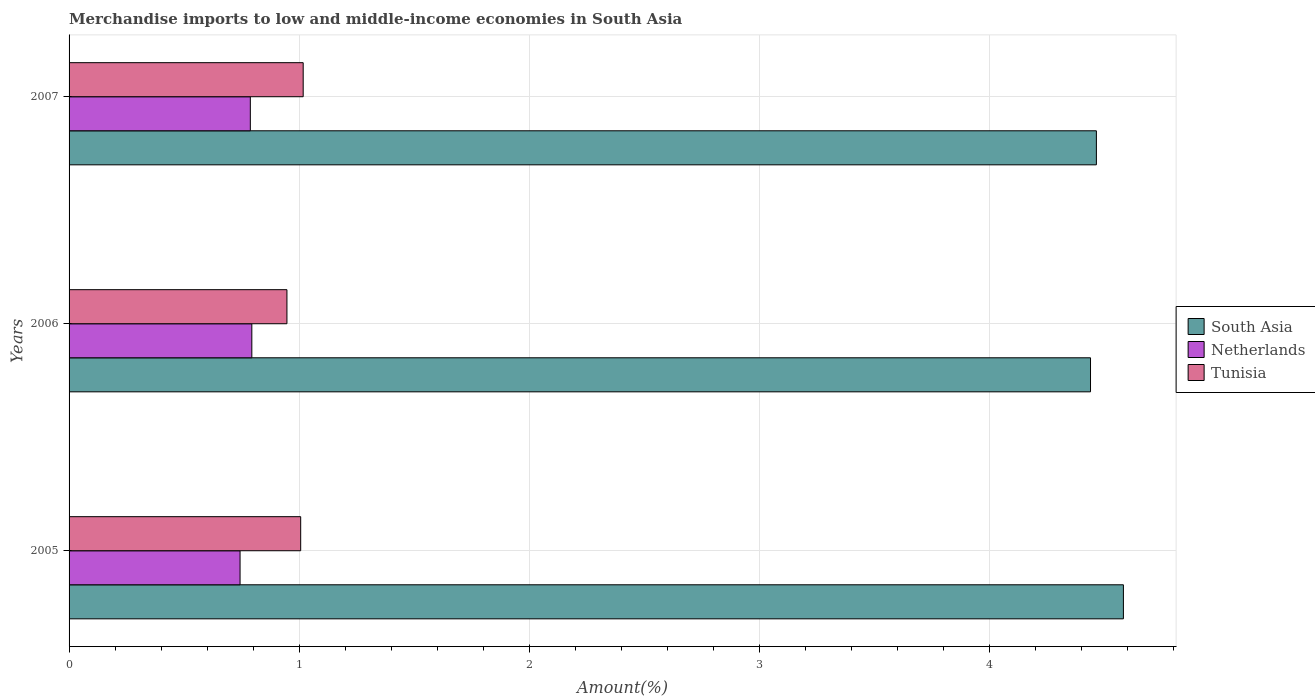How many different coloured bars are there?
Your answer should be compact. 3. How many bars are there on the 3rd tick from the top?
Make the answer very short. 3. What is the percentage of amount earned from merchandise imports in South Asia in 2007?
Offer a very short reply. 4.47. Across all years, what is the maximum percentage of amount earned from merchandise imports in Netherlands?
Make the answer very short. 0.79. Across all years, what is the minimum percentage of amount earned from merchandise imports in Tunisia?
Provide a short and direct response. 0.95. In which year was the percentage of amount earned from merchandise imports in Tunisia maximum?
Your response must be concise. 2007. In which year was the percentage of amount earned from merchandise imports in Tunisia minimum?
Offer a very short reply. 2006. What is the total percentage of amount earned from merchandise imports in South Asia in the graph?
Offer a terse response. 13.49. What is the difference between the percentage of amount earned from merchandise imports in Tunisia in 2005 and that in 2007?
Ensure brevity in your answer.  -0.01. What is the difference between the percentage of amount earned from merchandise imports in Tunisia in 2006 and the percentage of amount earned from merchandise imports in South Asia in 2007?
Give a very brief answer. -3.52. What is the average percentage of amount earned from merchandise imports in Tunisia per year?
Keep it short and to the point. 0.99. In the year 2006, what is the difference between the percentage of amount earned from merchandise imports in Netherlands and percentage of amount earned from merchandise imports in Tunisia?
Make the answer very short. -0.15. What is the ratio of the percentage of amount earned from merchandise imports in Tunisia in 2005 to that in 2006?
Offer a terse response. 1.06. What is the difference between the highest and the second highest percentage of amount earned from merchandise imports in South Asia?
Provide a short and direct response. 0.12. What is the difference between the highest and the lowest percentage of amount earned from merchandise imports in South Asia?
Your response must be concise. 0.14. In how many years, is the percentage of amount earned from merchandise imports in Tunisia greater than the average percentage of amount earned from merchandise imports in Tunisia taken over all years?
Your answer should be very brief. 2. What does the 2nd bar from the bottom in 2005 represents?
Offer a terse response. Netherlands. Is it the case that in every year, the sum of the percentage of amount earned from merchandise imports in Netherlands and percentage of amount earned from merchandise imports in Tunisia is greater than the percentage of amount earned from merchandise imports in South Asia?
Keep it short and to the point. No. Are all the bars in the graph horizontal?
Provide a short and direct response. Yes. How many years are there in the graph?
Your answer should be very brief. 3. What is the difference between two consecutive major ticks on the X-axis?
Ensure brevity in your answer.  1. Are the values on the major ticks of X-axis written in scientific E-notation?
Ensure brevity in your answer.  No. Where does the legend appear in the graph?
Your answer should be very brief. Center right. How many legend labels are there?
Keep it short and to the point. 3. What is the title of the graph?
Give a very brief answer. Merchandise imports to low and middle-income economies in South Asia. Does "Montenegro" appear as one of the legend labels in the graph?
Ensure brevity in your answer.  No. What is the label or title of the X-axis?
Give a very brief answer. Amount(%). What is the Amount(%) in South Asia in 2005?
Keep it short and to the point. 4.58. What is the Amount(%) in Netherlands in 2005?
Make the answer very short. 0.74. What is the Amount(%) in Tunisia in 2005?
Ensure brevity in your answer.  1.01. What is the Amount(%) in South Asia in 2006?
Provide a short and direct response. 4.44. What is the Amount(%) in Netherlands in 2006?
Provide a succinct answer. 0.79. What is the Amount(%) in Tunisia in 2006?
Make the answer very short. 0.95. What is the Amount(%) of South Asia in 2007?
Provide a short and direct response. 4.47. What is the Amount(%) of Netherlands in 2007?
Keep it short and to the point. 0.79. What is the Amount(%) of Tunisia in 2007?
Keep it short and to the point. 1.02. Across all years, what is the maximum Amount(%) of South Asia?
Make the answer very short. 4.58. Across all years, what is the maximum Amount(%) of Netherlands?
Provide a short and direct response. 0.79. Across all years, what is the maximum Amount(%) of Tunisia?
Ensure brevity in your answer.  1.02. Across all years, what is the minimum Amount(%) in South Asia?
Offer a terse response. 4.44. Across all years, what is the minimum Amount(%) of Netherlands?
Provide a succinct answer. 0.74. Across all years, what is the minimum Amount(%) of Tunisia?
Your response must be concise. 0.95. What is the total Amount(%) in South Asia in the graph?
Provide a succinct answer. 13.49. What is the total Amount(%) in Netherlands in the graph?
Provide a succinct answer. 2.33. What is the total Amount(%) of Tunisia in the graph?
Your response must be concise. 2.97. What is the difference between the Amount(%) in South Asia in 2005 and that in 2006?
Give a very brief answer. 0.14. What is the difference between the Amount(%) in Netherlands in 2005 and that in 2006?
Keep it short and to the point. -0.05. What is the difference between the Amount(%) in Tunisia in 2005 and that in 2006?
Your answer should be compact. 0.06. What is the difference between the Amount(%) in South Asia in 2005 and that in 2007?
Your response must be concise. 0.12. What is the difference between the Amount(%) in Netherlands in 2005 and that in 2007?
Ensure brevity in your answer.  -0.04. What is the difference between the Amount(%) of Tunisia in 2005 and that in 2007?
Give a very brief answer. -0.01. What is the difference between the Amount(%) of South Asia in 2006 and that in 2007?
Your response must be concise. -0.03. What is the difference between the Amount(%) in Netherlands in 2006 and that in 2007?
Provide a succinct answer. 0.01. What is the difference between the Amount(%) in Tunisia in 2006 and that in 2007?
Provide a succinct answer. -0.07. What is the difference between the Amount(%) of South Asia in 2005 and the Amount(%) of Netherlands in 2006?
Your answer should be very brief. 3.79. What is the difference between the Amount(%) in South Asia in 2005 and the Amount(%) in Tunisia in 2006?
Ensure brevity in your answer.  3.64. What is the difference between the Amount(%) of Netherlands in 2005 and the Amount(%) of Tunisia in 2006?
Provide a short and direct response. -0.2. What is the difference between the Amount(%) of South Asia in 2005 and the Amount(%) of Netherlands in 2007?
Your answer should be very brief. 3.8. What is the difference between the Amount(%) in South Asia in 2005 and the Amount(%) in Tunisia in 2007?
Your response must be concise. 3.57. What is the difference between the Amount(%) of Netherlands in 2005 and the Amount(%) of Tunisia in 2007?
Your answer should be compact. -0.27. What is the difference between the Amount(%) of South Asia in 2006 and the Amount(%) of Netherlands in 2007?
Your response must be concise. 3.65. What is the difference between the Amount(%) in South Asia in 2006 and the Amount(%) in Tunisia in 2007?
Your answer should be very brief. 3.42. What is the difference between the Amount(%) in Netherlands in 2006 and the Amount(%) in Tunisia in 2007?
Your response must be concise. -0.22. What is the average Amount(%) of South Asia per year?
Offer a very short reply. 4.5. What is the average Amount(%) of Netherlands per year?
Your answer should be compact. 0.78. What is the average Amount(%) of Tunisia per year?
Offer a terse response. 0.99. In the year 2005, what is the difference between the Amount(%) of South Asia and Amount(%) of Netherlands?
Give a very brief answer. 3.84. In the year 2005, what is the difference between the Amount(%) in South Asia and Amount(%) in Tunisia?
Offer a very short reply. 3.58. In the year 2005, what is the difference between the Amount(%) of Netherlands and Amount(%) of Tunisia?
Your answer should be very brief. -0.26. In the year 2006, what is the difference between the Amount(%) of South Asia and Amount(%) of Netherlands?
Give a very brief answer. 3.65. In the year 2006, what is the difference between the Amount(%) in South Asia and Amount(%) in Tunisia?
Give a very brief answer. 3.49. In the year 2006, what is the difference between the Amount(%) of Netherlands and Amount(%) of Tunisia?
Give a very brief answer. -0.15. In the year 2007, what is the difference between the Amount(%) of South Asia and Amount(%) of Netherlands?
Make the answer very short. 3.68. In the year 2007, what is the difference between the Amount(%) of South Asia and Amount(%) of Tunisia?
Provide a succinct answer. 3.45. In the year 2007, what is the difference between the Amount(%) of Netherlands and Amount(%) of Tunisia?
Your answer should be compact. -0.23. What is the ratio of the Amount(%) of South Asia in 2005 to that in 2006?
Ensure brevity in your answer.  1.03. What is the ratio of the Amount(%) in Netherlands in 2005 to that in 2006?
Provide a short and direct response. 0.94. What is the ratio of the Amount(%) in Tunisia in 2005 to that in 2006?
Your response must be concise. 1.06. What is the ratio of the Amount(%) of South Asia in 2005 to that in 2007?
Make the answer very short. 1.03. What is the ratio of the Amount(%) of Netherlands in 2005 to that in 2007?
Ensure brevity in your answer.  0.94. What is the ratio of the Amount(%) in Tunisia in 2005 to that in 2007?
Offer a terse response. 0.99. What is the ratio of the Amount(%) in South Asia in 2006 to that in 2007?
Offer a terse response. 0.99. What is the ratio of the Amount(%) of Netherlands in 2006 to that in 2007?
Provide a succinct answer. 1.01. What is the ratio of the Amount(%) in Tunisia in 2006 to that in 2007?
Your answer should be very brief. 0.93. What is the difference between the highest and the second highest Amount(%) in South Asia?
Your answer should be very brief. 0.12. What is the difference between the highest and the second highest Amount(%) in Netherlands?
Your response must be concise. 0.01. What is the difference between the highest and the second highest Amount(%) in Tunisia?
Provide a short and direct response. 0.01. What is the difference between the highest and the lowest Amount(%) in South Asia?
Offer a very short reply. 0.14. What is the difference between the highest and the lowest Amount(%) of Netherlands?
Ensure brevity in your answer.  0.05. What is the difference between the highest and the lowest Amount(%) of Tunisia?
Your answer should be compact. 0.07. 